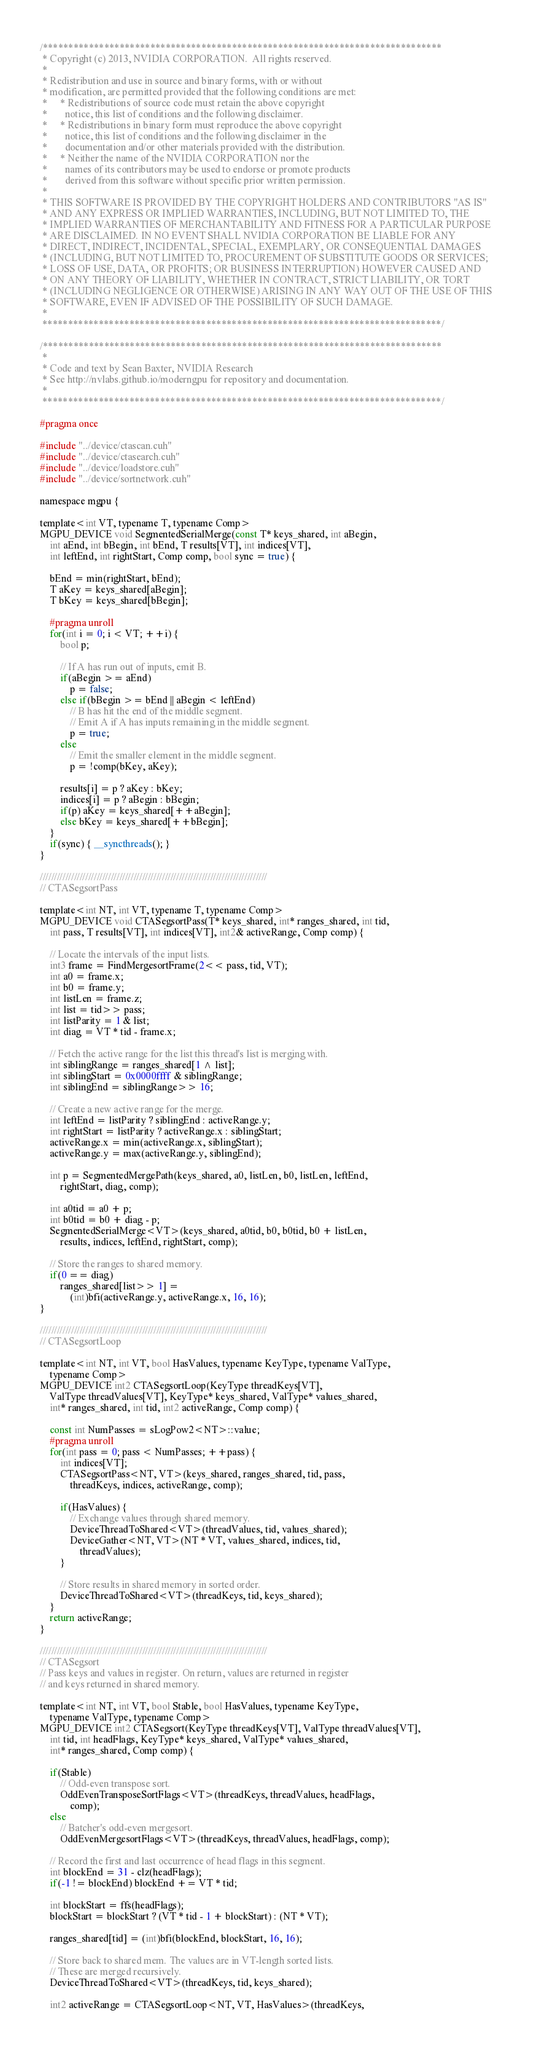<code> <loc_0><loc_0><loc_500><loc_500><_Cuda_>/******************************************************************************
 * Copyright (c) 2013, NVIDIA CORPORATION.  All rights reserved.
 * 
 * Redistribution and use in source and binary forms, with or without
 * modification, are permitted provided that the following conditions are met:
 *     * Redistributions of source code must retain the above copyright
 *       notice, this list of conditions and the following disclaimer.
 *     * Redistributions in binary form must reproduce the above copyright
 *       notice, this list of conditions and the following disclaimer in the
 *       documentation and/or other materials provided with the distribution.
 *     * Neither the name of the NVIDIA CORPORATION nor the
 *       names of its contributors may be used to endorse or promote products
 *       derived from this software without specific prior written permission.
 * 
 * THIS SOFTWARE IS PROVIDED BY THE COPYRIGHT HOLDERS AND CONTRIBUTORS "AS IS" 
 * AND ANY EXPRESS OR IMPLIED WARRANTIES, INCLUDING, BUT NOT LIMITED TO, THE
 * IMPLIED WARRANTIES OF MERCHANTABILITY AND FITNESS FOR A PARTICULAR PURPOSE 
 * ARE DISCLAIMED. IN NO EVENT SHALL NVIDIA CORPORATION BE LIABLE FOR ANY
 * DIRECT, INDIRECT, INCIDENTAL, SPECIAL, EXEMPLARY, OR CONSEQUENTIAL DAMAGES
 * (INCLUDING, BUT NOT LIMITED TO, PROCUREMENT OF SUBSTITUTE GOODS OR SERVICES;
 * LOSS OF USE, DATA, OR PROFITS; OR BUSINESS INTERRUPTION) HOWEVER CAUSED AND
 * ON ANY THEORY OF LIABILITY, WHETHER IN CONTRACT, STRICT LIABILITY, OR TORT
 * (INCLUDING NEGLIGENCE OR OTHERWISE) ARISING IN ANY WAY OUT OF THE USE OF THIS
 * SOFTWARE, EVEN IF ADVISED OF THE POSSIBILITY OF SUCH DAMAGE.
 *
 ******************************************************************************/

/******************************************************************************
 *
 * Code and text by Sean Baxter, NVIDIA Research
 * See http://nvlabs.github.io/moderngpu for repository and documentation.
 *
 ******************************************************************************/

#pragma once

#include "../device/ctascan.cuh"
#include "../device/ctasearch.cuh"
#include "../device/loadstore.cuh"
#include "../device/sortnetwork.cuh"

namespace mgpu {

template<int VT, typename T, typename Comp>
MGPU_DEVICE void SegmentedSerialMerge(const T* keys_shared, int aBegin,
	int aEnd, int bBegin, int bEnd, T results[VT], int indices[VT],
	int leftEnd, int rightStart, Comp comp, bool sync = true) {
		
	bEnd = min(rightStart, bEnd);
	T aKey = keys_shared[aBegin];
	T bKey = keys_shared[bBegin];

	#pragma unroll
	for(int i = 0; i < VT; ++i) {
		bool p;

		// If A has run out of inputs, emit B.
		if(aBegin >= aEnd)
			p = false;
		else if(bBegin >= bEnd || aBegin < leftEnd)
			// B has hit the end of the middle segment.
			// Emit A if A has inputs remaining in the middle segment.
			p = true;
		else
			// Emit the smaller element in the middle segment.
			p = !comp(bKey, aKey);
		
		results[i] = p ? aKey : bKey;
		indices[i] = p ? aBegin : bBegin;
		if(p) aKey = keys_shared[++aBegin];
		else bKey = keys_shared[++bBegin];
	}
	if(sync) { __syncthreads(); }
}

////////////////////////////////////////////////////////////////////////////////
// CTASegsortPass

template<int NT, int VT, typename T, typename Comp>
MGPU_DEVICE void CTASegsortPass(T* keys_shared, int* ranges_shared, int tid,
	int pass, T results[VT], int indices[VT], int2& activeRange, Comp comp) {

	// Locate the intervals of the input lists.
	int3 frame = FindMergesortFrame(2<< pass, tid, VT);
	int a0 = frame.x;
	int b0 = frame.y;
	int listLen = frame.z;
	int list = tid>> pass;
	int listParity = 1 & list;
	int diag = VT * tid - frame.x;

	// Fetch the active range for the list this thread's list is merging with.
	int siblingRange = ranges_shared[1 ^ list];
	int siblingStart = 0x0000ffff & siblingRange;
	int siblingEnd = siblingRange>> 16;
	
	// Create a new active range for the merge.
	int leftEnd = listParity ? siblingEnd : activeRange.y;
	int rightStart = listParity ? activeRange.x : siblingStart;
	activeRange.x = min(activeRange.x, siblingStart);
	activeRange.y = max(activeRange.y, siblingEnd);

	int p = SegmentedMergePath(keys_shared, a0, listLen, b0, listLen, leftEnd, 
		rightStart, diag, comp);

	int a0tid = a0 + p;
	int b0tid = b0 + diag - p;
	SegmentedSerialMerge<VT>(keys_shared, a0tid, b0, b0tid, b0 + listLen, 
		results, indices, leftEnd, rightStart, comp);

	// Store the ranges to shared memory.
	if(0 == diag)
		ranges_shared[list>> 1] = 
			(int)bfi(activeRange.y, activeRange.x, 16, 16);
}

////////////////////////////////////////////////////////////////////////////////
// CTASegsortLoop

template<int NT, int VT, bool HasValues, typename KeyType, typename ValType,
	typename Comp>
MGPU_DEVICE int2 CTASegsortLoop(KeyType threadKeys[VT], 
	ValType threadValues[VT], KeyType* keys_shared, ValType* values_shared, 
	int* ranges_shared, int tid, int2 activeRange, Comp comp) {

	const int NumPasses = sLogPow2<NT>::value;
	#pragma unroll
	for(int pass = 0; pass < NumPasses; ++pass) {
		int indices[VT];
		CTASegsortPass<NT, VT>(keys_shared, ranges_shared, tid, pass,
			threadKeys, indices, activeRange, comp);

		if(HasValues) {
			// Exchange values through shared memory.
			DeviceThreadToShared<VT>(threadValues, tid, values_shared);
			DeviceGather<NT, VT>(NT * VT, values_shared, indices, tid, 
				threadValues);
		}

		// Store results in shared memory in sorted order.
		DeviceThreadToShared<VT>(threadKeys, tid, keys_shared);
	}
	return activeRange;
}

////////////////////////////////////////////////////////////////////////////////
// CTASegsort
// Pass keys and values in register. On return, values are returned in register
// and keys returned in shared memory.

template<int NT, int VT, bool Stable, bool HasValues, typename KeyType,
	typename ValType, typename Comp>
MGPU_DEVICE int2 CTASegsort(KeyType threadKeys[VT], ValType threadValues[VT],
	int tid, int headFlags, KeyType* keys_shared, ValType* values_shared,
	int* ranges_shared, Comp comp) {

	if(Stable)
		// Odd-even transpose sort.
		OddEvenTransposeSortFlags<VT>(threadKeys, threadValues, headFlags,
			comp);
	else 
		// Batcher's odd-even mergesort.
		OddEvenMergesortFlags<VT>(threadKeys, threadValues, headFlags, comp);	

	// Record the first and last occurrence of head flags in this segment.
	int blockEnd = 31 - clz(headFlags);
	if(-1 != blockEnd) blockEnd += VT * tid;

	int blockStart = ffs(headFlags);
	blockStart = blockStart ? (VT * tid - 1 + blockStart) : (NT * VT);

	ranges_shared[tid] = (int)bfi(blockEnd, blockStart, 16, 16);

	// Store back to shared mem. The values are in VT-length sorted lists.
	// These are merged recursively.
	DeviceThreadToShared<VT>(threadKeys, tid, keys_shared);

	int2 activeRange = CTASegsortLoop<NT, VT, HasValues>(threadKeys,</code> 